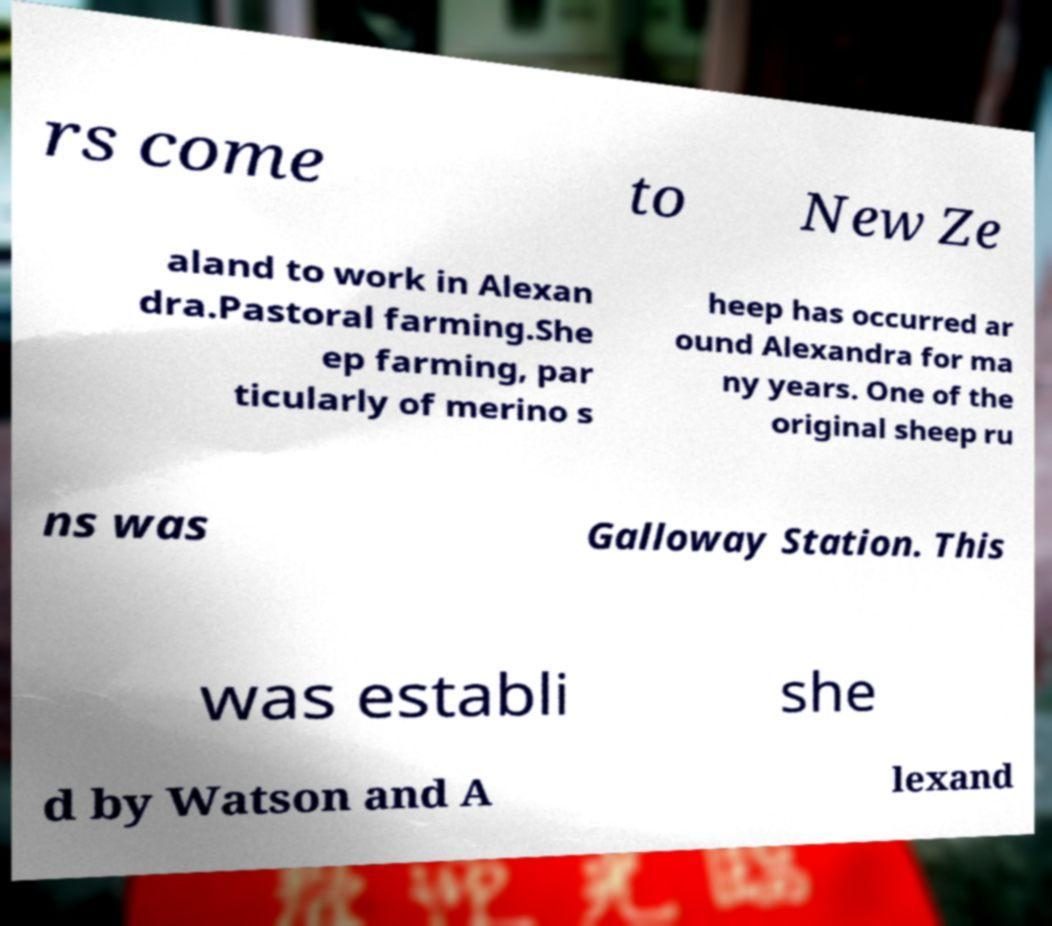What messages or text are displayed in this image? I need them in a readable, typed format. rs come to New Ze aland to work in Alexan dra.Pastoral farming.She ep farming, par ticularly of merino s heep has occurred ar ound Alexandra for ma ny years. One of the original sheep ru ns was Galloway Station. This was establi she d by Watson and A lexand 